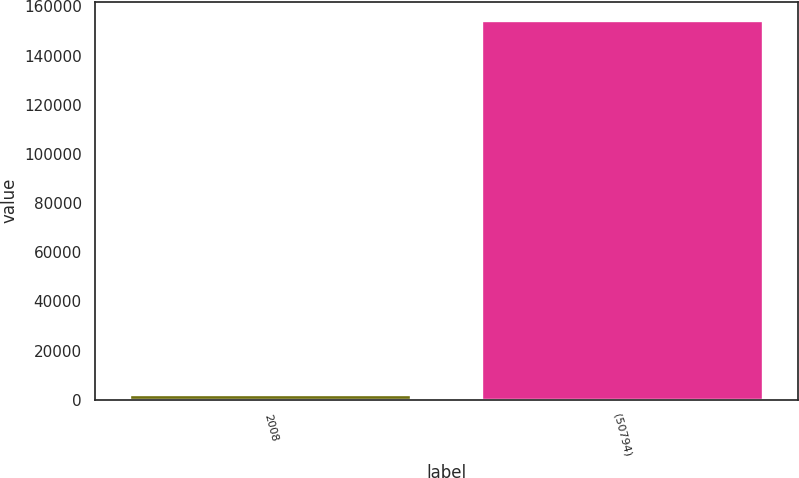Convert chart. <chart><loc_0><loc_0><loc_500><loc_500><bar_chart><fcel>2008<fcel>(50794)<nl><fcel>2007<fcel>154176<nl></chart> 